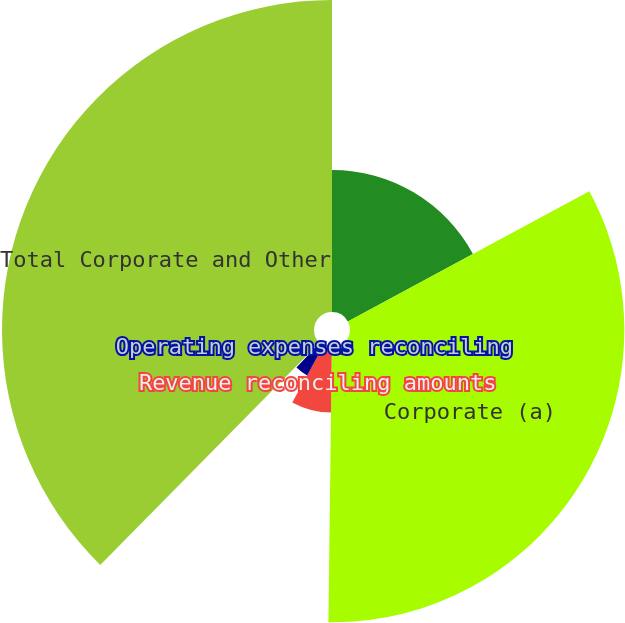Convert chart to OTSL. <chart><loc_0><loc_0><loc_500><loc_500><pie_chart><fcel>Year Ended June 30<fcel>Corporate (a)<fcel>Revenue reconciling amounts<fcel>Cost of revenue reconciling<fcel>Operating expenses reconciling<fcel>Total Corporate and Other<nl><fcel>17.13%<fcel>33.07%<fcel>7.79%<fcel>4.07%<fcel>0.34%<fcel>37.61%<nl></chart> 